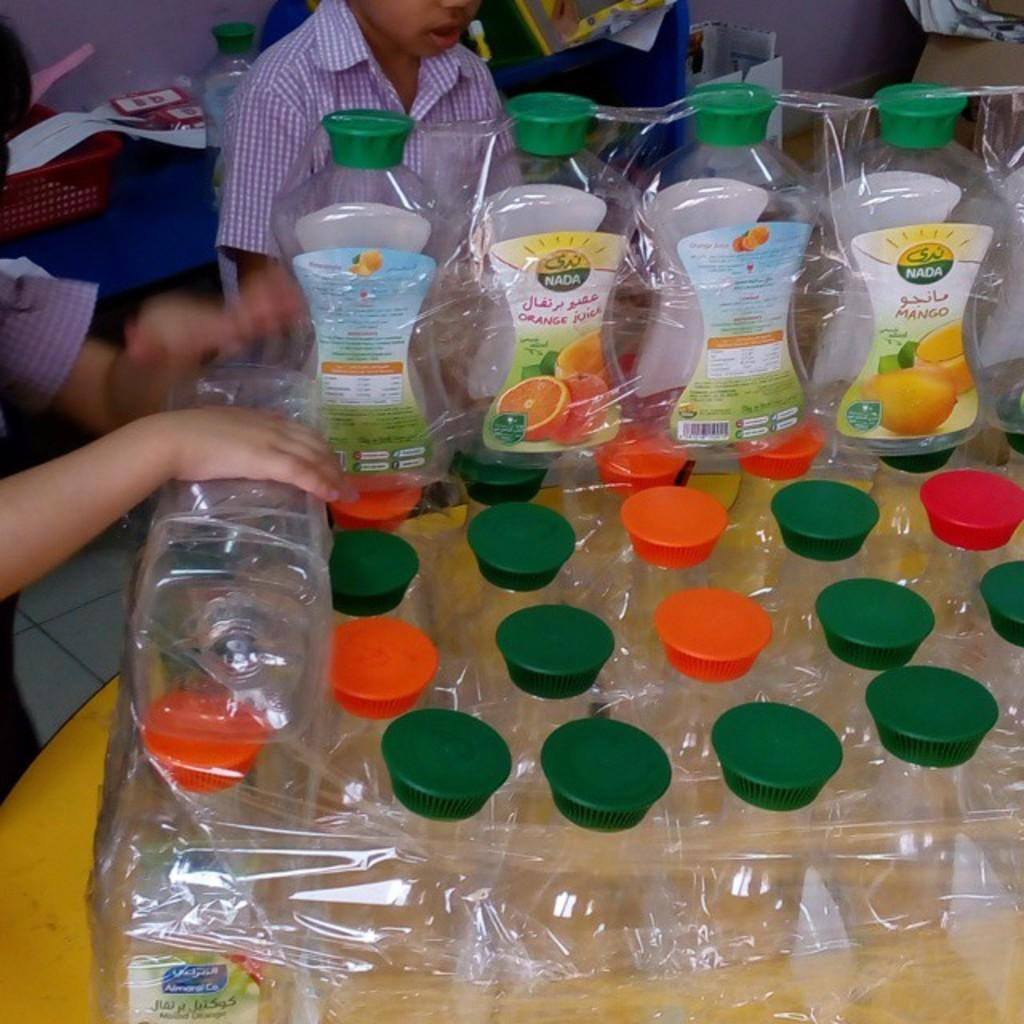<image>
Offer a succinct explanation of the picture presented. Empty bottles with orange and green lids with a label that has Nada on it 